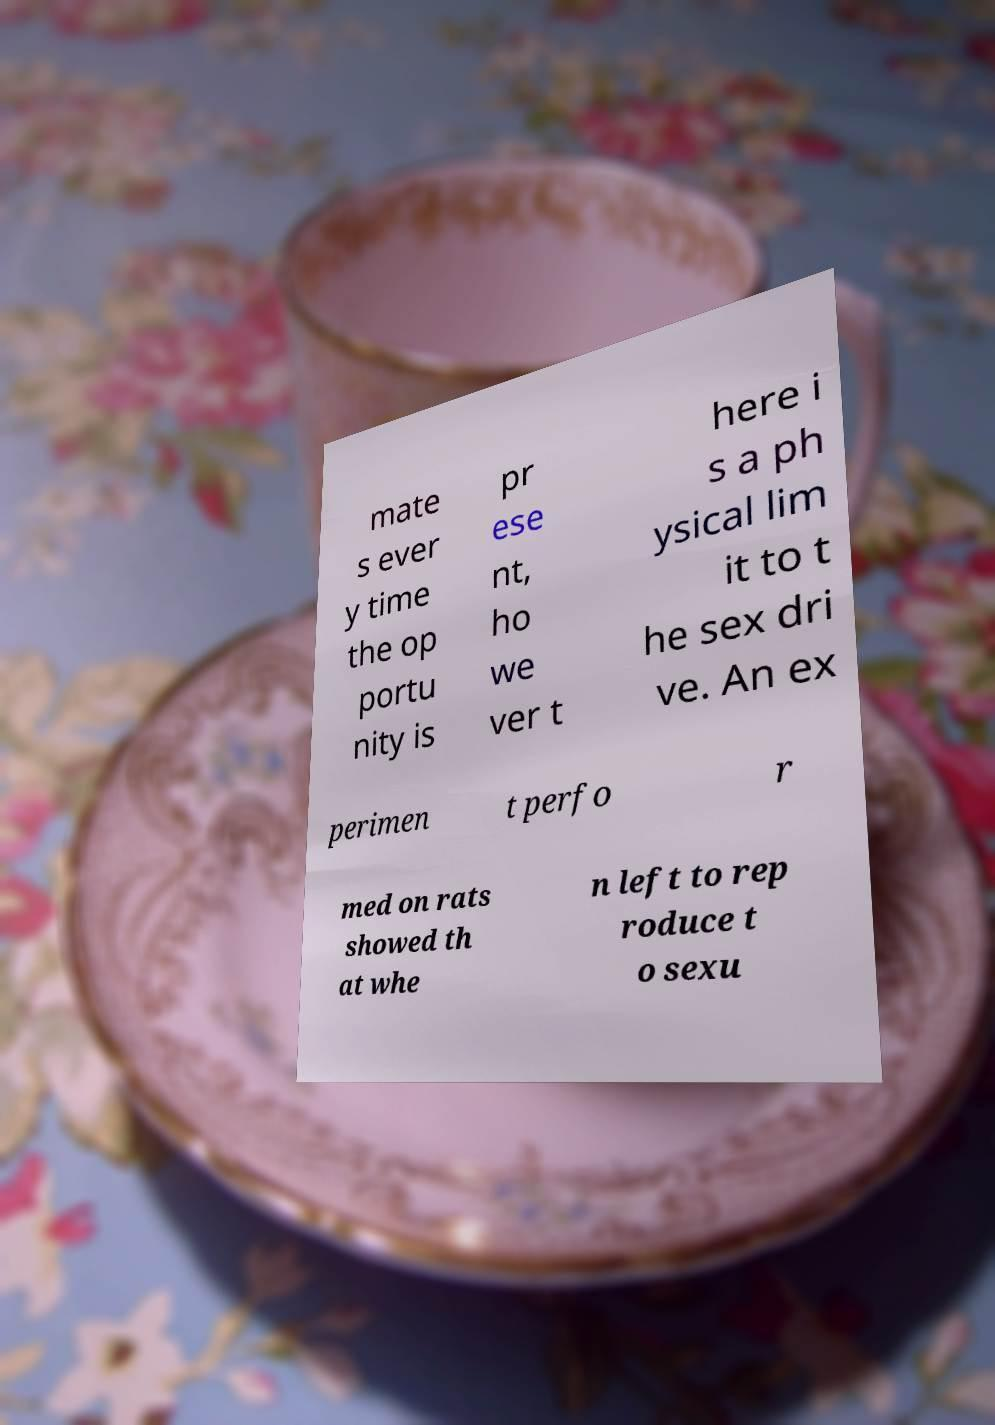For documentation purposes, I need the text within this image transcribed. Could you provide that? mate s ever y time the op portu nity is pr ese nt, ho we ver t here i s a ph ysical lim it to t he sex dri ve. An ex perimen t perfo r med on rats showed th at whe n left to rep roduce t o sexu 